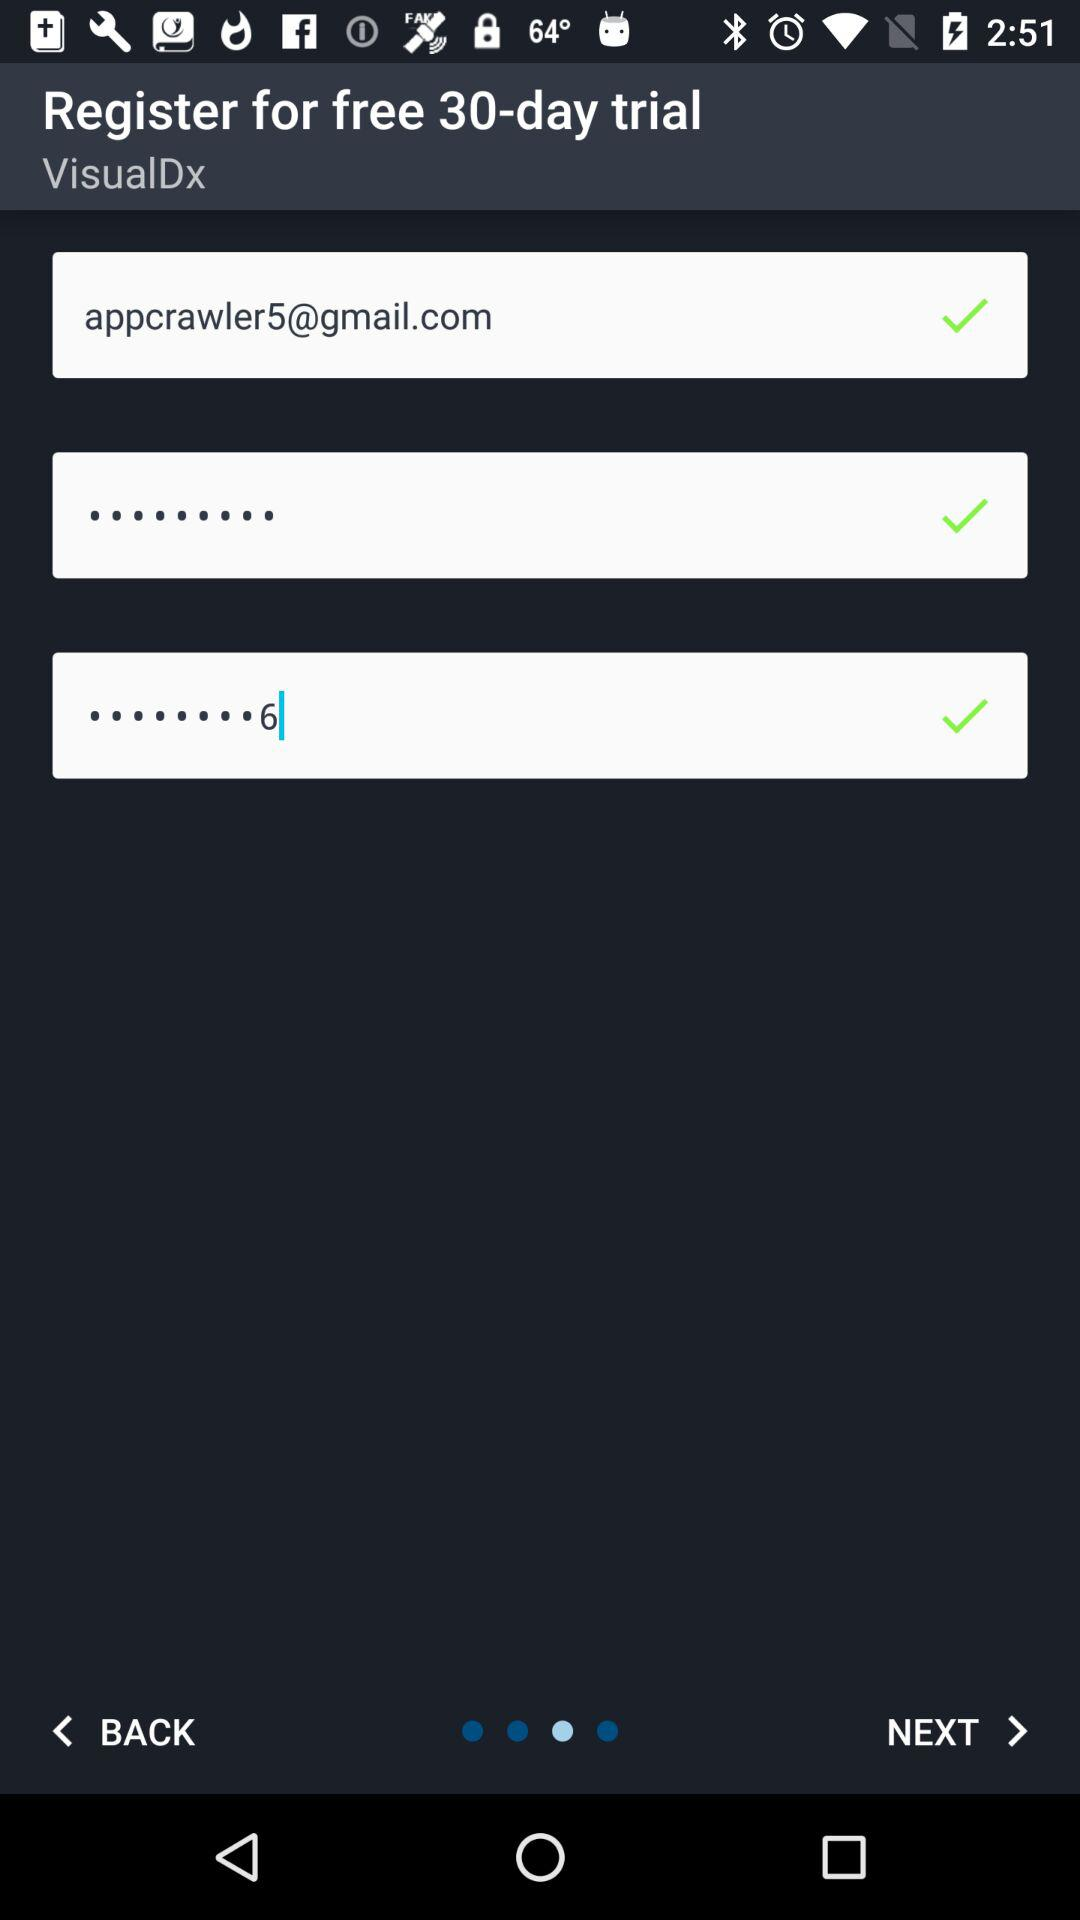Is trial free or paid? The trial is free. 